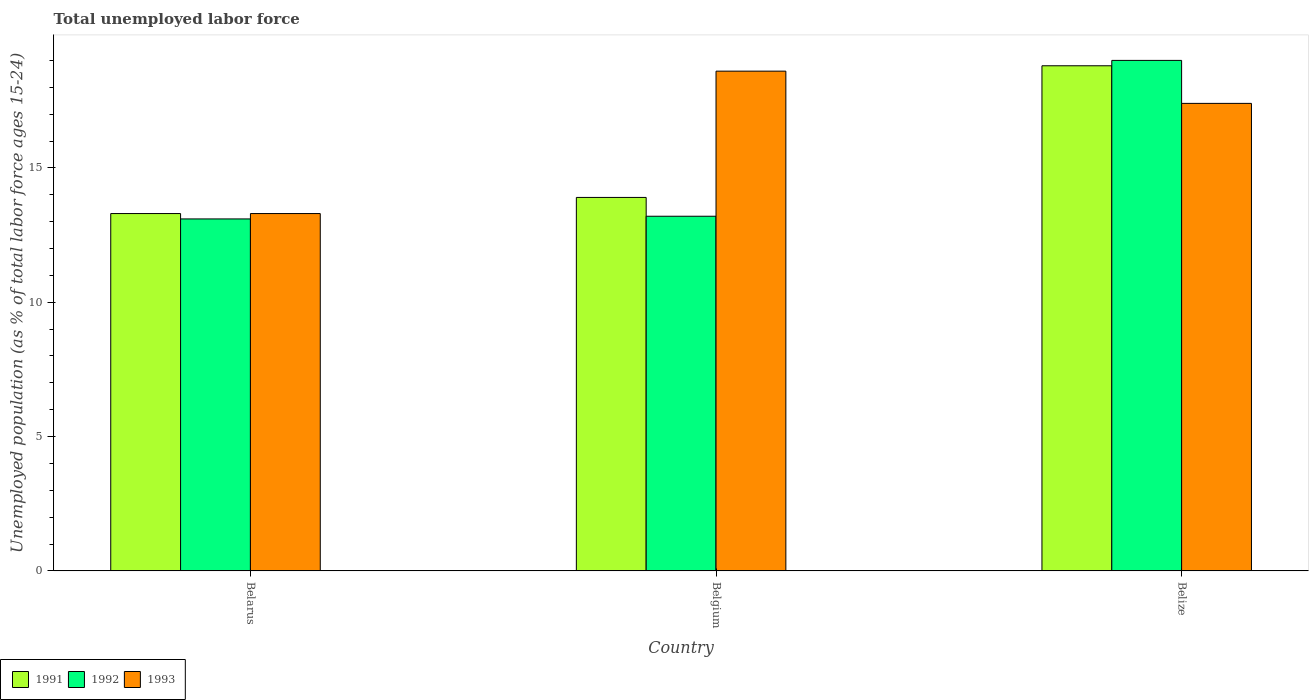How many different coloured bars are there?
Keep it short and to the point. 3. Are the number of bars on each tick of the X-axis equal?
Your answer should be very brief. Yes. How many bars are there on the 1st tick from the right?
Give a very brief answer. 3. In how many cases, is the number of bars for a given country not equal to the number of legend labels?
Provide a succinct answer. 0. What is the percentage of unemployed population in in 1991 in Belarus?
Your answer should be very brief. 13.3. Across all countries, what is the maximum percentage of unemployed population in in 1993?
Your answer should be compact. 18.6. Across all countries, what is the minimum percentage of unemployed population in in 1993?
Offer a terse response. 13.3. In which country was the percentage of unemployed population in in 1992 minimum?
Offer a very short reply. Belarus. What is the total percentage of unemployed population in in 1993 in the graph?
Offer a terse response. 49.3. What is the difference between the percentage of unemployed population in in 1992 in Belarus and that in Belize?
Your answer should be compact. -5.9. What is the difference between the percentage of unemployed population in in 1991 in Belize and the percentage of unemployed population in in 1993 in Belarus?
Your answer should be very brief. 5.5. What is the average percentage of unemployed population in in 1992 per country?
Offer a very short reply. 15.1. What is the difference between the percentage of unemployed population in of/in 1991 and percentage of unemployed population in of/in 1993 in Belgium?
Your response must be concise. -4.7. In how many countries, is the percentage of unemployed population in in 1992 greater than 11 %?
Give a very brief answer. 3. What is the ratio of the percentage of unemployed population in in 1993 in Belgium to that in Belize?
Offer a very short reply. 1.07. Is the percentage of unemployed population in in 1993 in Belgium less than that in Belize?
Make the answer very short. No. Is the difference between the percentage of unemployed population in in 1991 in Belgium and Belize greater than the difference between the percentage of unemployed population in in 1993 in Belgium and Belize?
Give a very brief answer. No. What is the difference between the highest and the second highest percentage of unemployed population in in 1993?
Your answer should be very brief. -1.2. What is the difference between the highest and the lowest percentage of unemployed population in in 1991?
Your answer should be very brief. 5.5. Is the sum of the percentage of unemployed population in in 1991 in Belarus and Belize greater than the maximum percentage of unemployed population in in 1992 across all countries?
Provide a succinct answer. Yes. What does the 1st bar from the left in Belize represents?
Your answer should be compact. 1991. Is it the case that in every country, the sum of the percentage of unemployed population in in 1992 and percentage of unemployed population in in 1993 is greater than the percentage of unemployed population in in 1991?
Keep it short and to the point. Yes. Are the values on the major ticks of Y-axis written in scientific E-notation?
Your answer should be compact. No. Does the graph contain any zero values?
Offer a very short reply. No. How many legend labels are there?
Make the answer very short. 3. What is the title of the graph?
Your response must be concise. Total unemployed labor force. What is the label or title of the Y-axis?
Your answer should be compact. Unemployed population (as % of total labor force ages 15-24). What is the Unemployed population (as % of total labor force ages 15-24) of 1991 in Belarus?
Offer a terse response. 13.3. What is the Unemployed population (as % of total labor force ages 15-24) in 1992 in Belarus?
Your answer should be very brief. 13.1. What is the Unemployed population (as % of total labor force ages 15-24) of 1993 in Belarus?
Offer a terse response. 13.3. What is the Unemployed population (as % of total labor force ages 15-24) in 1991 in Belgium?
Your answer should be very brief. 13.9. What is the Unemployed population (as % of total labor force ages 15-24) in 1992 in Belgium?
Keep it short and to the point. 13.2. What is the Unemployed population (as % of total labor force ages 15-24) of 1993 in Belgium?
Give a very brief answer. 18.6. What is the Unemployed population (as % of total labor force ages 15-24) of 1991 in Belize?
Offer a terse response. 18.8. What is the Unemployed population (as % of total labor force ages 15-24) in 1992 in Belize?
Provide a succinct answer. 19. What is the Unemployed population (as % of total labor force ages 15-24) of 1993 in Belize?
Keep it short and to the point. 17.4. Across all countries, what is the maximum Unemployed population (as % of total labor force ages 15-24) of 1991?
Give a very brief answer. 18.8. Across all countries, what is the maximum Unemployed population (as % of total labor force ages 15-24) of 1993?
Offer a very short reply. 18.6. Across all countries, what is the minimum Unemployed population (as % of total labor force ages 15-24) in 1991?
Your response must be concise. 13.3. Across all countries, what is the minimum Unemployed population (as % of total labor force ages 15-24) in 1992?
Your response must be concise. 13.1. Across all countries, what is the minimum Unemployed population (as % of total labor force ages 15-24) of 1993?
Provide a succinct answer. 13.3. What is the total Unemployed population (as % of total labor force ages 15-24) in 1991 in the graph?
Keep it short and to the point. 46. What is the total Unemployed population (as % of total labor force ages 15-24) in 1992 in the graph?
Your answer should be very brief. 45.3. What is the total Unemployed population (as % of total labor force ages 15-24) in 1993 in the graph?
Provide a short and direct response. 49.3. What is the difference between the Unemployed population (as % of total labor force ages 15-24) in 1992 in Belarus and that in Belgium?
Provide a short and direct response. -0.1. What is the difference between the Unemployed population (as % of total labor force ages 15-24) in 1993 in Belarus and that in Belgium?
Provide a succinct answer. -5.3. What is the difference between the Unemployed population (as % of total labor force ages 15-24) of 1991 in Belarus and that in Belize?
Provide a succinct answer. -5.5. What is the difference between the Unemployed population (as % of total labor force ages 15-24) of 1992 in Belarus and that in Belize?
Keep it short and to the point. -5.9. What is the difference between the Unemployed population (as % of total labor force ages 15-24) in 1993 in Belarus and that in Belize?
Your answer should be compact. -4.1. What is the difference between the Unemployed population (as % of total labor force ages 15-24) of 1991 in Belgium and that in Belize?
Your answer should be very brief. -4.9. What is the difference between the Unemployed population (as % of total labor force ages 15-24) of 1992 in Belgium and that in Belize?
Provide a succinct answer. -5.8. What is the difference between the Unemployed population (as % of total labor force ages 15-24) in 1991 in Belarus and the Unemployed population (as % of total labor force ages 15-24) in 1993 in Belgium?
Provide a short and direct response. -5.3. What is the difference between the Unemployed population (as % of total labor force ages 15-24) in 1991 in Belarus and the Unemployed population (as % of total labor force ages 15-24) in 1993 in Belize?
Your answer should be compact. -4.1. What is the difference between the Unemployed population (as % of total labor force ages 15-24) in 1992 in Belgium and the Unemployed population (as % of total labor force ages 15-24) in 1993 in Belize?
Ensure brevity in your answer.  -4.2. What is the average Unemployed population (as % of total labor force ages 15-24) in 1991 per country?
Give a very brief answer. 15.33. What is the average Unemployed population (as % of total labor force ages 15-24) of 1993 per country?
Ensure brevity in your answer.  16.43. What is the difference between the Unemployed population (as % of total labor force ages 15-24) of 1991 and Unemployed population (as % of total labor force ages 15-24) of 1992 in Belarus?
Keep it short and to the point. 0.2. What is the difference between the Unemployed population (as % of total labor force ages 15-24) in 1992 and Unemployed population (as % of total labor force ages 15-24) in 1993 in Belarus?
Provide a short and direct response. -0.2. What is the difference between the Unemployed population (as % of total labor force ages 15-24) of 1991 and Unemployed population (as % of total labor force ages 15-24) of 1992 in Belgium?
Ensure brevity in your answer.  0.7. What is the difference between the Unemployed population (as % of total labor force ages 15-24) in 1992 and Unemployed population (as % of total labor force ages 15-24) in 1993 in Belgium?
Give a very brief answer. -5.4. What is the difference between the Unemployed population (as % of total labor force ages 15-24) in 1991 and Unemployed population (as % of total labor force ages 15-24) in 1992 in Belize?
Ensure brevity in your answer.  -0.2. What is the difference between the Unemployed population (as % of total labor force ages 15-24) of 1991 and Unemployed population (as % of total labor force ages 15-24) of 1993 in Belize?
Provide a short and direct response. 1.4. What is the difference between the Unemployed population (as % of total labor force ages 15-24) in 1992 and Unemployed population (as % of total labor force ages 15-24) in 1993 in Belize?
Ensure brevity in your answer.  1.6. What is the ratio of the Unemployed population (as % of total labor force ages 15-24) of 1991 in Belarus to that in Belgium?
Offer a very short reply. 0.96. What is the ratio of the Unemployed population (as % of total labor force ages 15-24) in 1993 in Belarus to that in Belgium?
Your answer should be compact. 0.72. What is the ratio of the Unemployed population (as % of total labor force ages 15-24) in 1991 in Belarus to that in Belize?
Give a very brief answer. 0.71. What is the ratio of the Unemployed population (as % of total labor force ages 15-24) in 1992 in Belarus to that in Belize?
Offer a very short reply. 0.69. What is the ratio of the Unemployed population (as % of total labor force ages 15-24) of 1993 in Belarus to that in Belize?
Your answer should be compact. 0.76. What is the ratio of the Unemployed population (as % of total labor force ages 15-24) of 1991 in Belgium to that in Belize?
Make the answer very short. 0.74. What is the ratio of the Unemployed population (as % of total labor force ages 15-24) in 1992 in Belgium to that in Belize?
Keep it short and to the point. 0.69. What is the ratio of the Unemployed population (as % of total labor force ages 15-24) of 1993 in Belgium to that in Belize?
Offer a terse response. 1.07. What is the difference between the highest and the second highest Unemployed population (as % of total labor force ages 15-24) of 1992?
Offer a terse response. 5.8. What is the difference between the highest and the second highest Unemployed population (as % of total labor force ages 15-24) of 1993?
Your answer should be very brief. 1.2. What is the difference between the highest and the lowest Unemployed population (as % of total labor force ages 15-24) of 1991?
Offer a terse response. 5.5. 